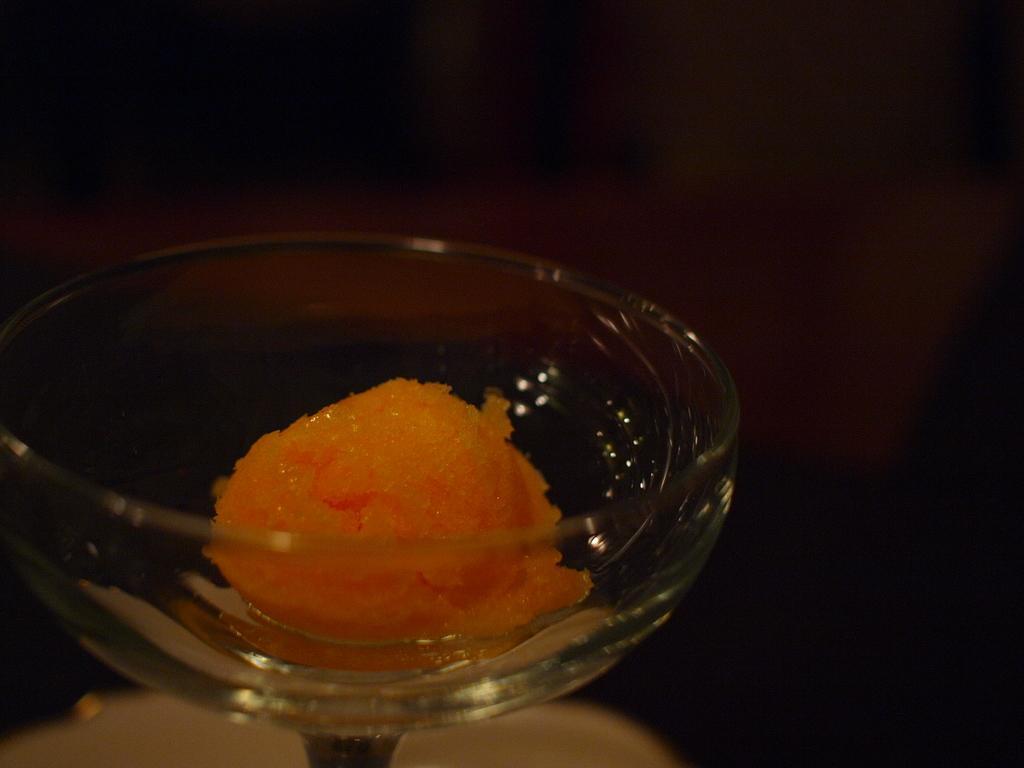Could you give a brief overview of what you see in this image? In this image we can see some food in a glass. 